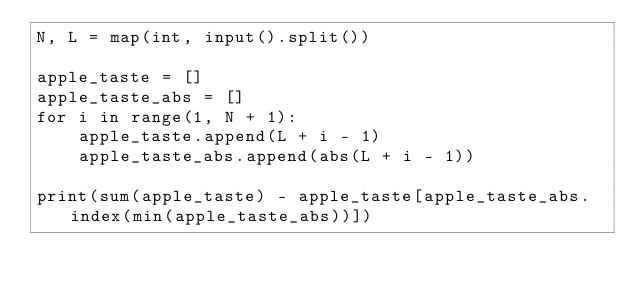Convert code to text. <code><loc_0><loc_0><loc_500><loc_500><_Python_>N, L = map(int, input().split())

apple_taste = []
apple_taste_abs = []
for i in range(1, N + 1):
    apple_taste.append(L + i - 1)
    apple_taste_abs.append(abs(L + i - 1))

print(sum(apple_taste) - apple_taste[apple_taste_abs.index(min(apple_taste_abs))])



</code> 